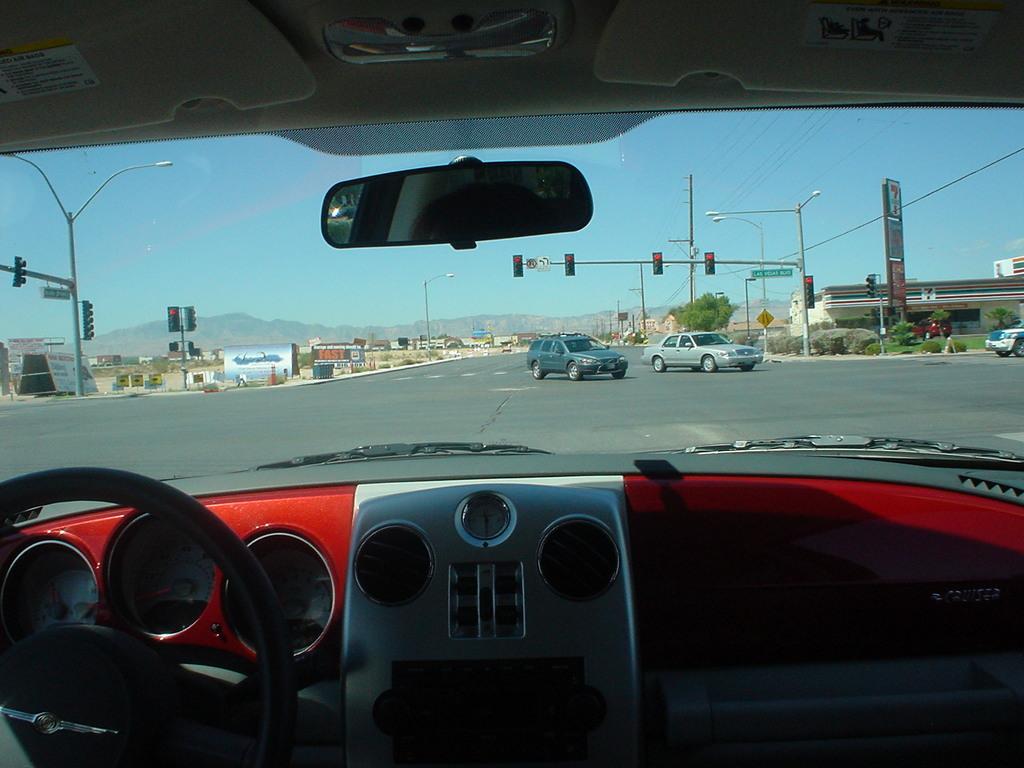How would you summarize this image in a sentence or two? In this picture I can see a road. There are some cars on the road. I can observe poles on either sides of the road to which lights are fixed. In the background there are hills and a sky. 